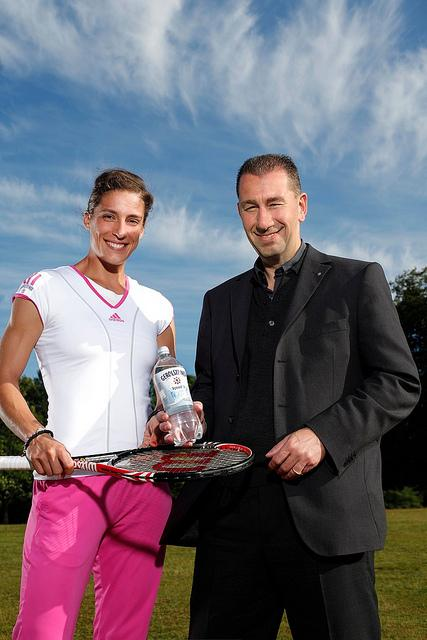What corporation made the shirt the woman is wearing? adidas 